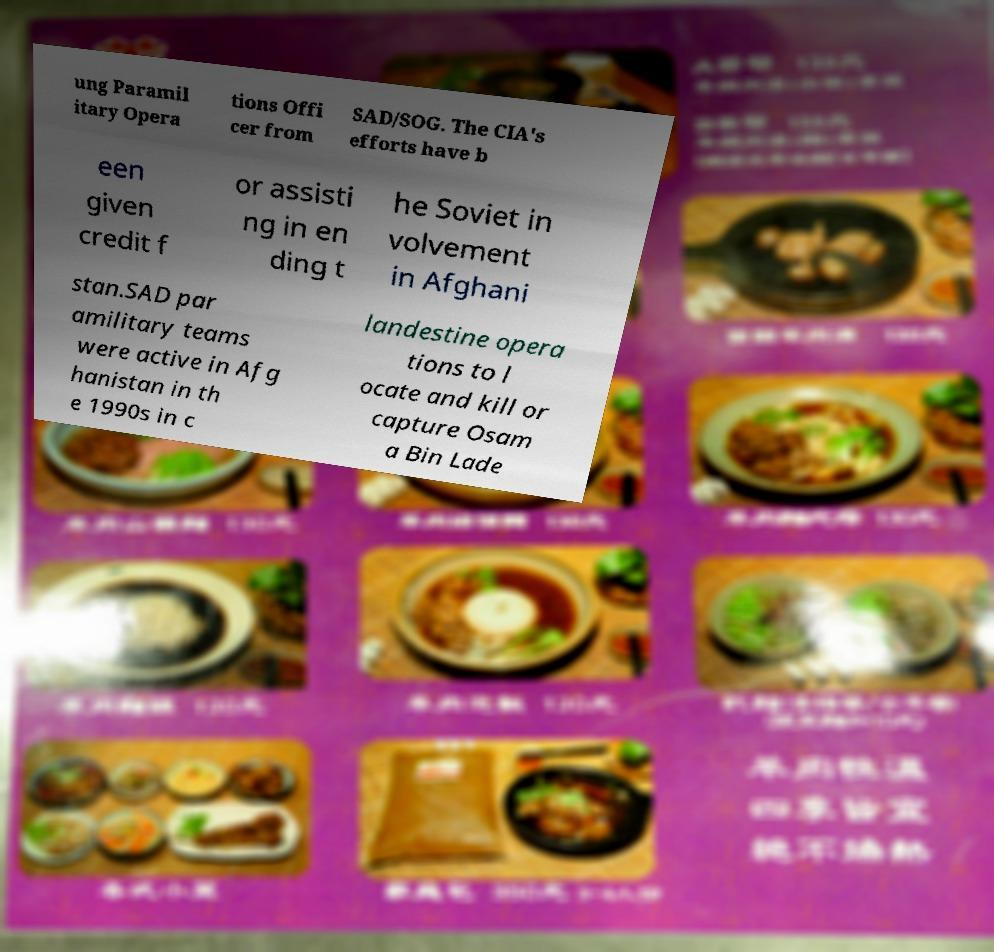Can you accurately transcribe the text from the provided image for me? ung Paramil itary Opera tions Offi cer from SAD/SOG. The CIA's efforts have b een given credit f or assisti ng in en ding t he Soviet in volvement in Afghani stan.SAD par amilitary teams were active in Afg hanistan in th e 1990s in c landestine opera tions to l ocate and kill or capture Osam a Bin Lade 